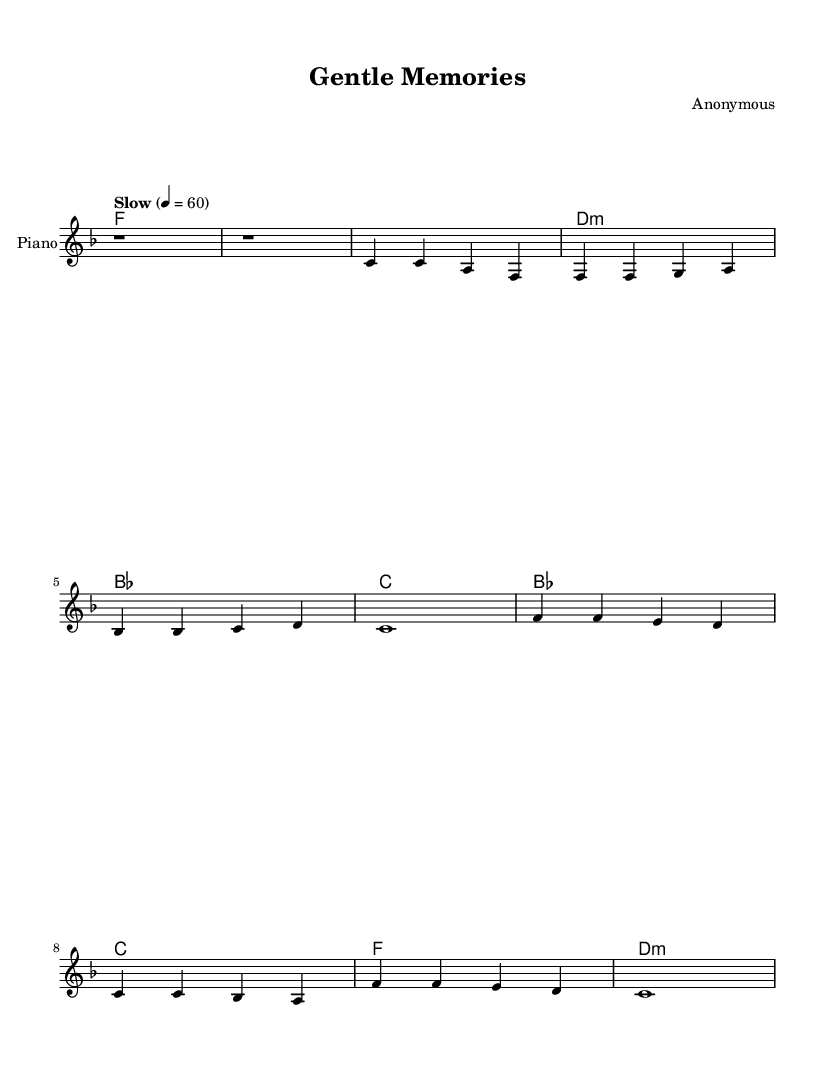What is the key signature of this music? The key signature is F major, indicated by one flat (B flat).
Answer: F major What is the time signature of the music? The time signature is 4/4, which means there are four beats in each measure.
Answer: 4/4 What is the tempo of this piece? The tempo is marked as "Slow" with a metronome marking of 60 beats per minute.
Answer: Slow, 60 How many measures are in the intro? The intro consists of two measures, indicated by the two 'r1' symbols.
Answer: 2 measures What is the first chord played in the verse? The first chord in the verse is F major, as indicated in the harmonies section.
Answer: F What type of progression is used in the chorus? The chorus follows a I-IV-vi-V progression, which is common in R&B ballads.
Answer: I-IV-vi-V What is a defining feature of Smooth R&B ballads from the 1960s and 1970s in this music? A defining feature is the use of emotional melodies in conjunction with simple, yet expressive chord progressions.
Answer: Emotional melodies and simple chord progressions 